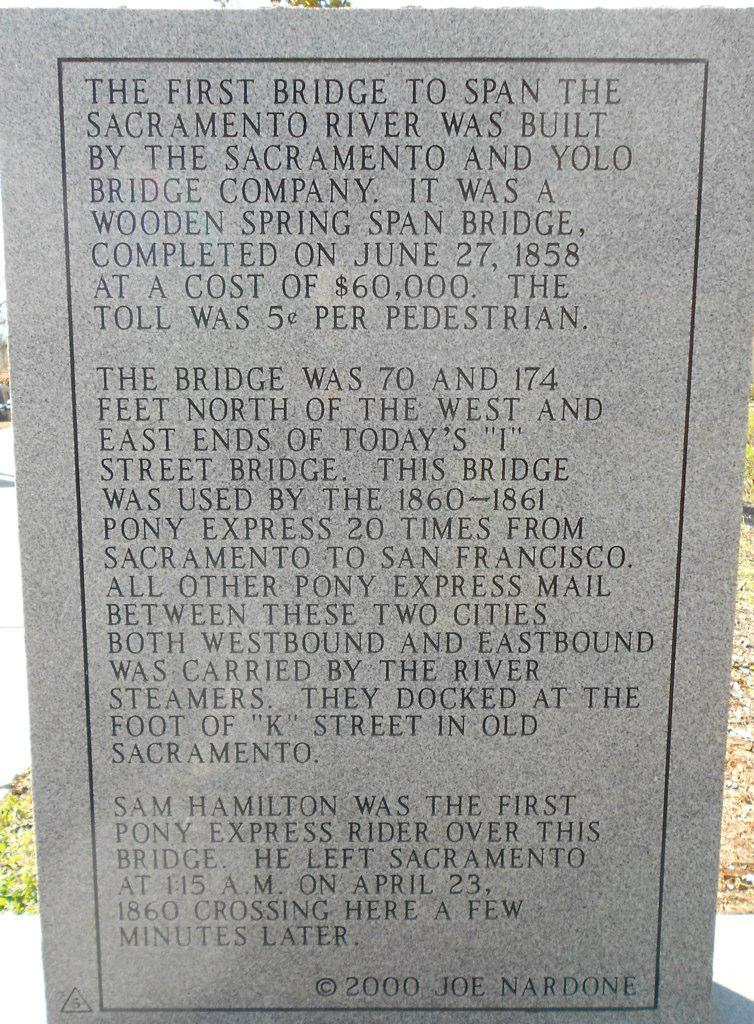What is the main object in the image? There is a headstone in the image. What is written on the headstone? Matter is written on the headstone. What type of juice can be seen being poured on the headstone in the image? There is no juice present in the image, and nothing is being poured on the headstone. 